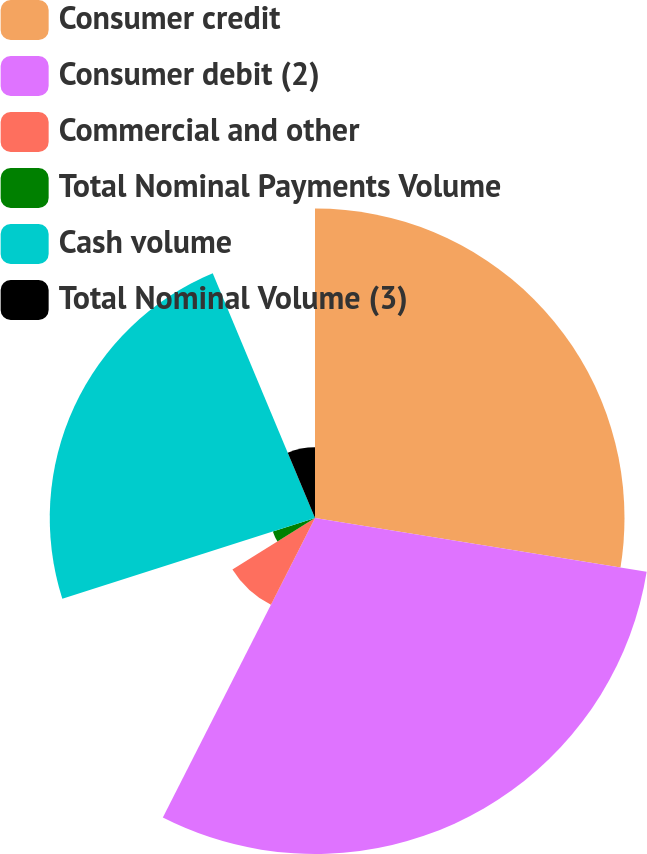Convert chart. <chart><loc_0><loc_0><loc_500><loc_500><pie_chart><fcel>Consumer credit<fcel>Consumer debit (2)<fcel>Commercial and other<fcel>Total Nominal Payments Volume<fcel>Cash volume<fcel>Total Nominal Volume (3)<nl><fcel>27.56%<fcel>29.92%<fcel>8.66%<fcel>3.94%<fcel>23.62%<fcel>6.3%<nl></chart> 